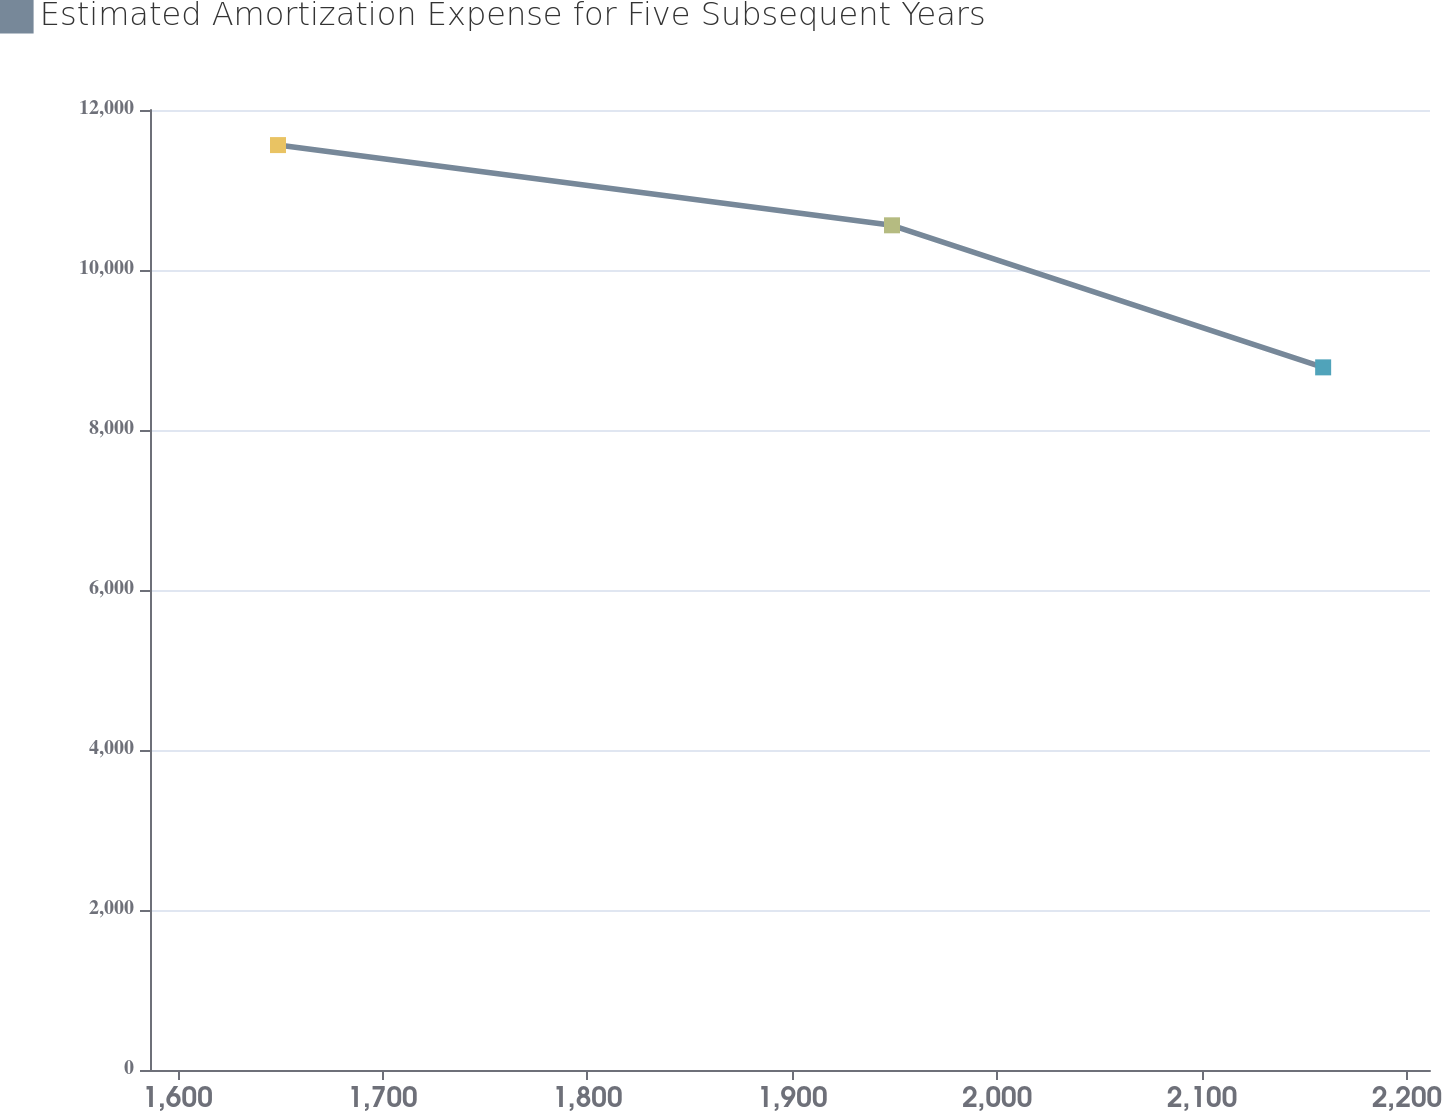Convert chart. <chart><loc_0><loc_0><loc_500><loc_500><line_chart><ecel><fcel>Estimated Amortization Expense for Five Subsequent Years<nl><fcel>1648.99<fcel>11561.4<nl><fcel>1948.66<fcel>10558.6<nl><fcel>2159.09<fcel>8782.96<nl><fcel>2216.4<fcel>9432.06<nl><fcel>2273.71<fcel>14179.6<nl></chart> 